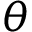Convert formula to latex. <formula><loc_0><loc_0><loc_500><loc_500>\theta</formula> 